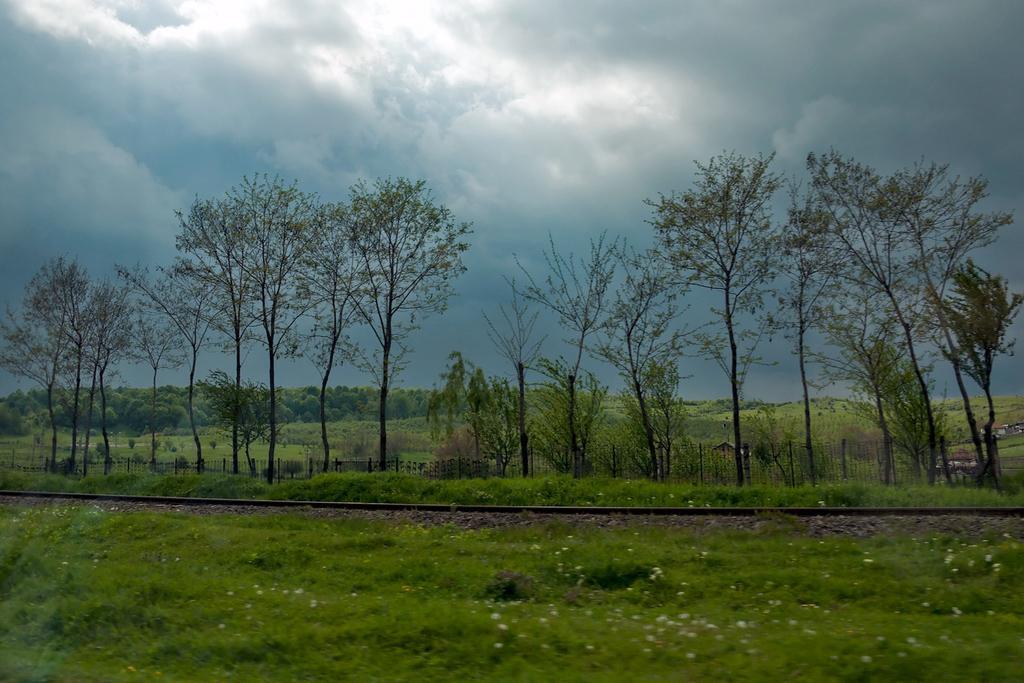Describe this image in one or two sentences. In this image there is a railway track in the middle. At the top there is the sky. In the background there are so many trees. At the bottom there are plants. 